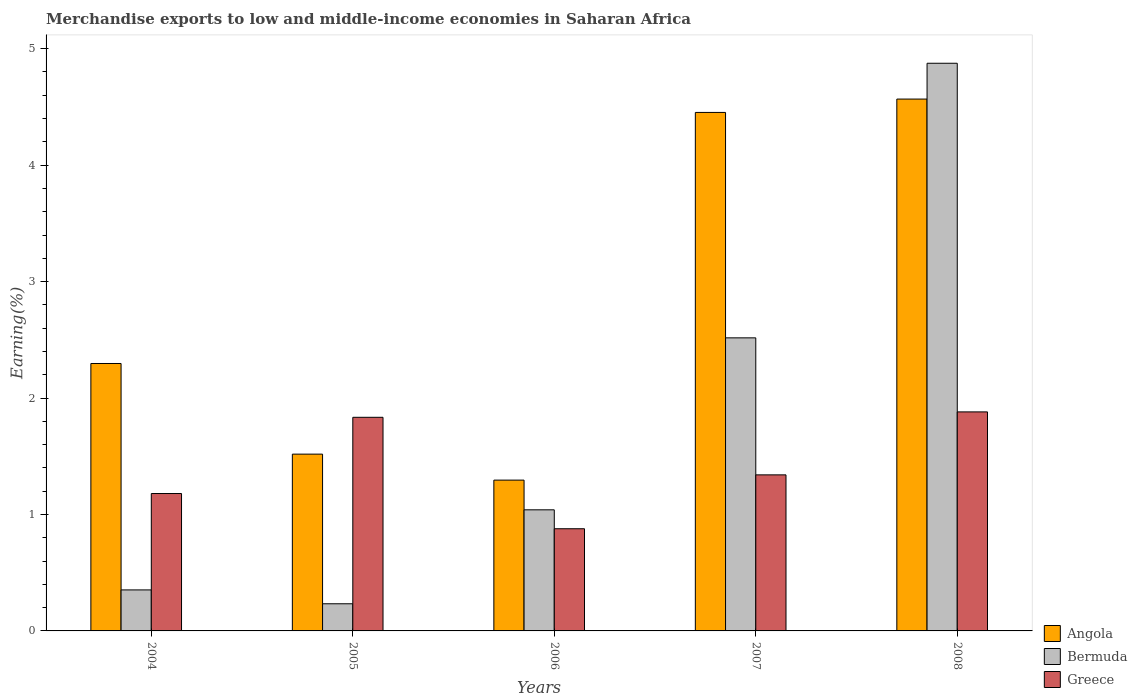How many different coloured bars are there?
Make the answer very short. 3. How many groups of bars are there?
Give a very brief answer. 5. Are the number of bars per tick equal to the number of legend labels?
Give a very brief answer. Yes. How many bars are there on the 3rd tick from the left?
Offer a terse response. 3. How many bars are there on the 1st tick from the right?
Ensure brevity in your answer.  3. What is the label of the 2nd group of bars from the left?
Your response must be concise. 2005. In how many cases, is the number of bars for a given year not equal to the number of legend labels?
Ensure brevity in your answer.  0. What is the percentage of amount earned from merchandise exports in Angola in 2008?
Your answer should be very brief. 4.57. Across all years, what is the maximum percentage of amount earned from merchandise exports in Bermuda?
Keep it short and to the point. 4.87. Across all years, what is the minimum percentage of amount earned from merchandise exports in Bermuda?
Keep it short and to the point. 0.23. In which year was the percentage of amount earned from merchandise exports in Angola maximum?
Give a very brief answer. 2008. What is the total percentage of amount earned from merchandise exports in Angola in the graph?
Ensure brevity in your answer.  14.13. What is the difference between the percentage of amount earned from merchandise exports in Greece in 2005 and that in 2007?
Offer a very short reply. 0.49. What is the difference between the percentage of amount earned from merchandise exports in Bermuda in 2006 and the percentage of amount earned from merchandise exports in Angola in 2004?
Give a very brief answer. -1.26. What is the average percentage of amount earned from merchandise exports in Angola per year?
Your answer should be very brief. 2.83. In the year 2008, what is the difference between the percentage of amount earned from merchandise exports in Angola and percentage of amount earned from merchandise exports in Bermuda?
Provide a succinct answer. -0.31. In how many years, is the percentage of amount earned from merchandise exports in Bermuda greater than 1.2 %?
Provide a short and direct response. 2. What is the ratio of the percentage of amount earned from merchandise exports in Angola in 2004 to that in 2008?
Your answer should be compact. 0.5. Is the difference between the percentage of amount earned from merchandise exports in Angola in 2004 and 2005 greater than the difference between the percentage of amount earned from merchandise exports in Bermuda in 2004 and 2005?
Your response must be concise. Yes. What is the difference between the highest and the second highest percentage of amount earned from merchandise exports in Greece?
Keep it short and to the point. 0.05. What is the difference between the highest and the lowest percentage of amount earned from merchandise exports in Angola?
Make the answer very short. 3.27. What does the 3rd bar from the left in 2005 represents?
Give a very brief answer. Greece. What does the 3rd bar from the right in 2006 represents?
Make the answer very short. Angola. Is it the case that in every year, the sum of the percentage of amount earned from merchandise exports in Greece and percentage of amount earned from merchandise exports in Bermuda is greater than the percentage of amount earned from merchandise exports in Angola?
Make the answer very short. No. Are all the bars in the graph horizontal?
Provide a succinct answer. No. Are the values on the major ticks of Y-axis written in scientific E-notation?
Make the answer very short. No. Does the graph contain any zero values?
Ensure brevity in your answer.  No. Does the graph contain grids?
Make the answer very short. No. Where does the legend appear in the graph?
Make the answer very short. Bottom right. How many legend labels are there?
Your answer should be compact. 3. What is the title of the graph?
Give a very brief answer. Merchandise exports to low and middle-income economies in Saharan Africa. What is the label or title of the Y-axis?
Keep it short and to the point. Earning(%). What is the Earning(%) of Angola in 2004?
Your answer should be compact. 2.3. What is the Earning(%) of Bermuda in 2004?
Offer a terse response. 0.35. What is the Earning(%) of Greece in 2004?
Provide a succinct answer. 1.18. What is the Earning(%) of Angola in 2005?
Provide a short and direct response. 1.52. What is the Earning(%) in Bermuda in 2005?
Your response must be concise. 0.23. What is the Earning(%) of Greece in 2005?
Offer a terse response. 1.83. What is the Earning(%) in Angola in 2006?
Your answer should be very brief. 1.3. What is the Earning(%) of Bermuda in 2006?
Your answer should be very brief. 1.04. What is the Earning(%) of Greece in 2006?
Provide a short and direct response. 0.88. What is the Earning(%) in Angola in 2007?
Your response must be concise. 4.45. What is the Earning(%) in Bermuda in 2007?
Provide a short and direct response. 2.52. What is the Earning(%) in Greece in 2007?
Provide a succinct answer. 1.34. What is the Earning(%) in Angola in 2008?
Offer a terse response. 4.57. What is the Earning(%) of Bermuda in 2008?
Your response must be concise. 4.87. What is the Earning(%) in Greece in 2008?
Offer a very short reply. 1.88. Across all years, what is the maximum Earning(%) of Angola?
Offer a very short reply. 4.57. Across all years, what is the maximum Earning(%) of Bermuda?
Your answer should be very brief. 4.87. Across all years, what is the maximum Earning(%) in Greece?
Keep it short and to the point. 1.88. Across all years, what is the minimum Earning(%) of Angola?
Give a very brief answer. 1.3. Across all years, what is the minimum Earning(%) in Bermuda?
Your answer should be very brief. 0.23. Across all years, what is the minimum Earning(%) in Greece?
Your answer should be compact. 0.88. What is the total Earning(%) of Angola in the graph?
Make the answer very short. 14.13. What is the total Earning(%) of Bermuda in the graph?
Ensure brevity in your answer.  9.02. What is the total Earning(%) in Greece in the graph?
Give a very brief answer. 7.11. What is the difference between the Earning(%) of Angola in 2004 and that in 2005?
Give a very brief answer. 0.78. What is the difference between the Earning(%) of Bermuda in 2004 and that in 2005?
Ensure brevity in your answer.  0.12. What is the difference between the Earning(%) in Greece in 2004 and that in 2005?
Provide a short and direct response. -0.65. What is the difference between the Earning(%) in Angola in 2004 and that in 2006?
Offer a very short reply. 1. What is the difference between the Earning(%) of Bermuda in 2004 and that in 2006?
Offer a terse response. -0.69. What is the difference between the Earning(%) of Greece in 2004 and that in 2006?
Offer a terse response. 0.3. What is the difference between the Earning(%) of Angola in 2004 and that in 2007?
Give a very brief answer. -2.16. What is the difference between the Earning(%) of Bermuda in 2004 and that in 2007?
Offer a terse response. -2.16. What is the difference between the Earning(%) of Greece in 2004 and that in 2007?
Your response must be concise. -0.16. What is the difference between the Earning(%) in Angola in 2004 and that in 2008?
Keep it short and to the point. -2.27. What is the difference between the Earning(%) of Bermuda in 2004 and that in 2008?
Offer a terse response. -4.52. What is the difference between the Earning(%) of Greece in 2004 and that in 2008?
Your response must be concise. -0.7. What is the difference between the Earning(%) of Angola in 2005 and that in 2006?
Your answer should be very brief. 0.22. What is the difference between the Earning(%) in Bermuda in 2005 and that in 2006?
Ensure brevity in your answer.  -0.81. What is the difference between the Earning(%) of Greece in 2005 and that in 2006?
Your answer should be compact. 0.96. What is the difference between the Earning(%) in Angola in 2005 and that in 2007?
Give a very brief answer. -2.93. What is the difference between the Earning(%) of Bermuda in 2005 and that in 2007?
Provide a succinct answer. -2.28. What is the difference between the Earning(%) of Greece in 2005 and that in 2007?
Offer a very short reply. 0.49. What is the difference between the Earning(%) in Angola in 2005 and that in 2008?
Give a very brief answer. -3.05. What is the difference between the Earning(%) in Bermuda in 2005 and that in 2008?
Provide a short and direct response. -4.64. What is the difference between the Earning(%) of Greece in 2005 and that in 2008?
Provide a succinct answer. -0.05. What is the difference between the Earning(%) in Angola in 2006 and that in 2007?
Your answer should be very brief. -3.16. What is the difference between the Earning(%) of Bermuda in 2006 and that in 2007?
Give a very brief answer. -1.48. What is the difference between the Earning(%) of Greece in 2006 and that in 2007?
Ensure brevity in your answer.  -0.46. What is the difference between the Earning(%) of Angola in 2006 and that in 2008?
Offer a very short reply. -3.27. What is the difference between the Earning(%) in Bermuda in 2006 and that in 2008?
Your answer should be compact. -3.83. What is the difference between the Earning(%) in Greece in 2006 and that in 2008?
Keep it short and to the point. -1. What is the difference between the Earning(%) of Angola in 2007 and that in 2008?
Offer a very short reply. -0.11. What is the difference between the Earning(%) of Bermuda in 2007 and that in 2008?
Your answer should be very brief. -2.36. What is the difference between the Earning(%) in Greece in 2007 and that in 2008?
Provide a succinct answer. -0.54. What is the difference between the Earning(%) of Angola in 2004 and the Earning(%) of Bermuda in 2005?
Make the answer very short. 2.06. What is the difference between the Earning(%) in Angola in 2004 and the Earning(%) in Greece in 2005?
Give a very brief answer. 0.46. What is the difference between the Earning(%) of Bermuda in 2004 and the Earning(%) of Greece in 2005?
Keep it short and to the point. -1.48. What is the difference between the Earning(%) of Angola in 2004 and the Earning(%) of Bermuda in 2006?
Your answer should be very brief. 1.26. What is the difference between the Earning(%) of Angola in 2004 and the Earning(%) of Greece in 2006?
Keep it short and to the point. 1.42. What is the difference between the Earning(%) of Bermuda in 2004 and the Earning(%) of Greece in 2006?
Offer a very short reply. -0.53. What is the difference between the Earning(%) in Angola in 2004 and the Earning(%) in Bermuda in 2007?
Make the answer very short. -0.22. What is the difference between the Earning(%) of Angola in 2004 and the Earning(%) of Greece in 2007?
Give a very brief answer. 0.96. What is the difference between the Earning(%) in Bermuda in 2004 and the Earning(%) in Greece in 2007?
Your answer should be compact. -0.99. What is the difference between the Earning(%) in Angola in 2004 and the Earning(%) in Bermuda in 2008?
Provide a short and direct response. -2.58. What is the difference between the Earning(%) in Angola in 2004 and the Earning(%) in Greece in 2008?
Your answer should be very brief. 0.42. What is the difference between the Earning(%) of Bermuda in 2004 and the Earning(%) of Greece in 2008?
Your response must be concise. -1.53. What is the difference between the Earning(%) of Angola in 2005 and the Earning(%) of Bermuda in 2006?
Your answer should be compact. 0.48. What is the difference between the Earning(%) in Angola in 2005 and the Earning(%) in Greece in 2006?
Your answer should be very brief. 0.64. What is the difference between the Earning(%) in Bermuda in 2005 and the Earning(%) in Greece in 2006?
Provide a succinct answer. -0.64. What is the difference between the Earning(%) of Angola in 2005 and the Earning(%) of Bermuda in 2007?
Your answer should be very brief. -1. What is the difference between the Earning(%) of Angola in 2005 and the Earning(%) of Greece in 2007?
Your response must be concise. 0.18. What is the difference between the Earning(%) of Bermuda in 2005 and the Earning(%) of Greece in 2007?
Keep it short and to the point. -1.11. What is the difference between the Earning(%) of Angola in 2005 and the Earning(%) of Bermuda in 2008?
Provide a succinct answer. -3.36. What is the difference between the Earning(%) of Angola in 2005 and the Earning(%) of Greece in 2008?
Your answer should be very brief. -0.36. What is the difference between the Earning(%) in Bermuda in 2005 and the Earning(%) in Greece in 2008?
Provide a short and direct response. -1.65. What is the difference between the Earning(%) of Angola in 2006 and the Earning(%) of Bermuda in 2007?
Keep it short and to the point. -1.22. What is the difference between the Earning(%) in Angola in 2006 and the Earning(%) in Greece in 2007?
Ensure brevity in your answer.  -0.04. What is the difference between the Earning(%) in Bermuda in 2006 and the Earning(%) in Greece in 2007?
Your answer should be very brief. -0.3. What is the difference between the Earning(%) of Angola in 2006 and the Earning(%) of Bermuda in 2008?
Your response must be concise. -3.58. What is the difference between the Earning(%) of Angola in 2006 and the Earning(%) of Greece in 2008?
Ensure brevity in your answer.  -0.59. What is the difference between the Earning(%) in Bermuda in 2006 and the Earning(%) in Greece in 2008?
Keep it short and to the point. -0.84. What is the difference between the Earning(%) of Angola in 2007 and the Earning(%) of Bermuda in 2008?
Offer a very short reply. -0.42. What is the difference between the Earning(%) of Angola in 2007 and the Earning(%) of Greece in 2008?
Offer a very short reply. 2.57. What is the difference between the Earning(%) in Bermuda in 2007 and the Earning(%) in Greece in 2008?
Make the answer very short. 0.64. What is the average Earning(%) of Angola per year?
Provide a short and direct response. 2.83. What is the average Earning(%) in Bermuda per year?
Provide a short and direct response. 1.8. What is the average Earning(%) of Greece per year?
Provide a succinct answer. 1.42. In the year 2004, what is the difference between the Earning(%) of Angola and Earning(%) of Bermuda?
Ensure brevity in your answer.  1.94. In the year 2004, what is the difference between the Earning(%) in Angola and Earning(%) in Greece?
Your answer should be compact. 1.12. In the year 2004, what is the difference between the Earning(%) in Bermuda and Earning(%) in Greece?
Your answer should be very brief. -0.83. In the year 2005, what is the difference between the Earning(%) in Angola and Earning(%) in Bermuda?
Provide a short and direct response. 1.29. In the year 2005, what is the difference between the Earning(%) of Angola and Earning(%) of Greece?
Provide a succinct answer. -0.32. In the year 2005, what is the difference between the Earning(%) of Bermuda and Earning(%) of Greece?
Provide a succinct answer. -1.6. In the year 2006, what is the difference between the Earning(%) in Angola and Earning(%) in Bermuda?
Provide a succinct answer. 0.26. In the year 2006, what is the difference between the Earning(%) in Angola and Earning(%) in Greece?
Provide a short and direct response. 0.42. In the year 2006, what is the difference between the Earning(%) of Bermuda and Earning(%) of Greece?
Your answer should be compact. 0.16. In the year 2007, what is the difference between the Earning(%) in Angola and Earning(%) in Bermuda?
Offer a very short reply. 1.94. In the year 2007, what is the difference between the Earning(%) in Angola and Earning(%) in Greece?
Your answer should be very brief. 3.11. In the year 2007, what is the difference between the Earning(%) of Bermuda and Earning(%) of Greece?
Provide a short and direct response. 1.18. In the year 2008, what is the difference between the Earning(%) of Angola and Earning(%) of Bermuda?
Keep it short and to the point. -0.31. In the year 2008, what is the difference between the Earning(%) of Angola and Earning(%) of Greece?
Make the answer very short. 2.69. In the year 2008, what is the difference between the Earning(%) of Bermuda and Earning(%) of Greece?
Make the answer very short. 2.99. What is the ratio of the Earning(%) in Angola in 2004 to that in 2005?
Your response must be concise. 1.51. What is the ratio of the Earning(%) in Bermuda in 2004 to that in 2005?
Offer a terse response. 1.51. What is the ratio of the Earning(%) in Greece in 2004 to that in 2005?
Your response must be concise. 0.64. What is the ratio of the Earning(%) in Angola in 2004 to that in 2006?
Make the answer very short. 1.77. What is the ratio of the Earning(%) in Bermuda in 2004 to that in 2006?
Offer a very short reply. 0.34. What is the ratio of the Earning(%) in Greece in 2004 to that in 2006?
Offer a terse response. 1.34. What is the ratio of the Earning(%) in Angola in 2004 to that in 2007?
Offer a very short reply. 0.52. What is the ratio of the Earning(%) of Bermuda in 2004 to that in 2007?
Your answer should be very brief. 0.14. What is the ratio of the Earning(%) in Greece in 2004 to that in 2007?
Your answer should be very brief. 0.88. What is the ratio of the Earning(%) in Angola in 2004 to that in 2008?
Ensure brevity in your answer.  0.5. What is the ratio of the Earning(%) in Bermuda in 2004 to that in 2008?
Make the answer very short. 0.07. What is the ratio of the Earning(%) in Greece in 2004 to that in 2008?
Make the answer very short. 0.63. What is the ratio of the Earning(%) in Angola in 2005 to that in 2006?
Your response must be concise. 1.17. What is the ratio of the Earning(%) of Bermuda in 2005 to that in 2006?
Provide a short and direct response. 0.22. What is the ratio of the Earning(%) of Greece in 2005 to that in 2006?
Offer a very short reply. 2.09. What is the ratio of the Earning(%) of Angola in 2005 to that in 2007?
Give a very brief answer. 0.34. What is the ratio of the Earning(%) in Bermuda in 2005 to that in 2007?
Give a very brief answer. 0.09. What is the ratio of the Earning(%) of Greece in 2005 to that in 2007?
Ensure brevity in your answer.  1.37. What is the ratio of the Earning(%) of Angola in 2005 to that in 2008?
Your response must be concise. 0.33. What is the ratio of the Earning(%) in Bermuda in 2005 to that in 2008?
Keep it short and to the point. 0.05. What is the ratio of the Earning(%) of Greece in 2005 to that in 2008?
Make the answer very short. 0.98. What is the ratio of the Earning(%) in Angola in 2006 to that in 2007?
Your answer should be compact. 0.29. What is the ratio of the Earning(%) in Bermuda in 2006 to that in 2007?
Your response must be concise. 0.41. What is the ratio of the Earning(%) of Greece in 2006 to that in 2007?
Your answer should be very brief. 0.65. What is the ratio of the Earning(%) in Angola in 2006 to that in 2008?
Offer a terse response. 0.28. What is the ratio of the Earning(%) in Bermuda in 2006 to that in 2008?
Your answer should be compact. 0.21. What is the ratio of the Earning(%) in Greece in 2006 to that in 2008?
Offer a terse response. 0.47. What is the ratio of the Earning(%) in Angola in 2007 to that in 2008?
Provide a short and direct response. 0.97. What is the ratio of the Earning(%) in Bermuda in 2007 to that in 2008?
Provide a succinct answer. 0.52. What is the ratio of the Earning(%) of Greece in 2007 to that in 2008?
Offer a terse response. 0.71. What is the difference between the highest and the second highest Earning(%) in Angola?
Give a very brief answer. 0.11. What is the difference between the highest and the second highest Earning(%) of Bermuda?
Your response must be concise. 2.36. What is the difference between the highest and the second highest Earning(%) in Greece?
Make the answer very short. 0.05. What is the difference between the highest and the lowest Earning(%) of Angola?
Make the answer very short. 3.27. What is the difference between the highest and the lowest Earning(%) in Bermuda?
Ensure brevity in your answer.  4.64. What is the difference between the highest and the lowest Earning(%) in Greece?
Your answer should be compact. 1. 